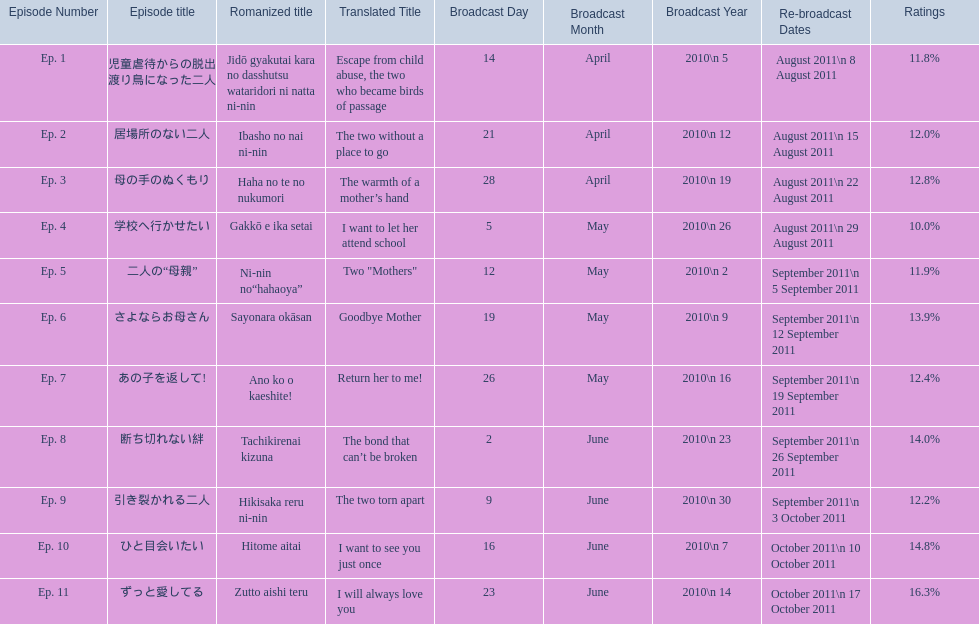Which episode was titled the two without a place to go? Ep. 2. What was the title of ep. 3? The warmth of a mother’s hand. Which episode had a rating of 10.0%? Ep. 4. 